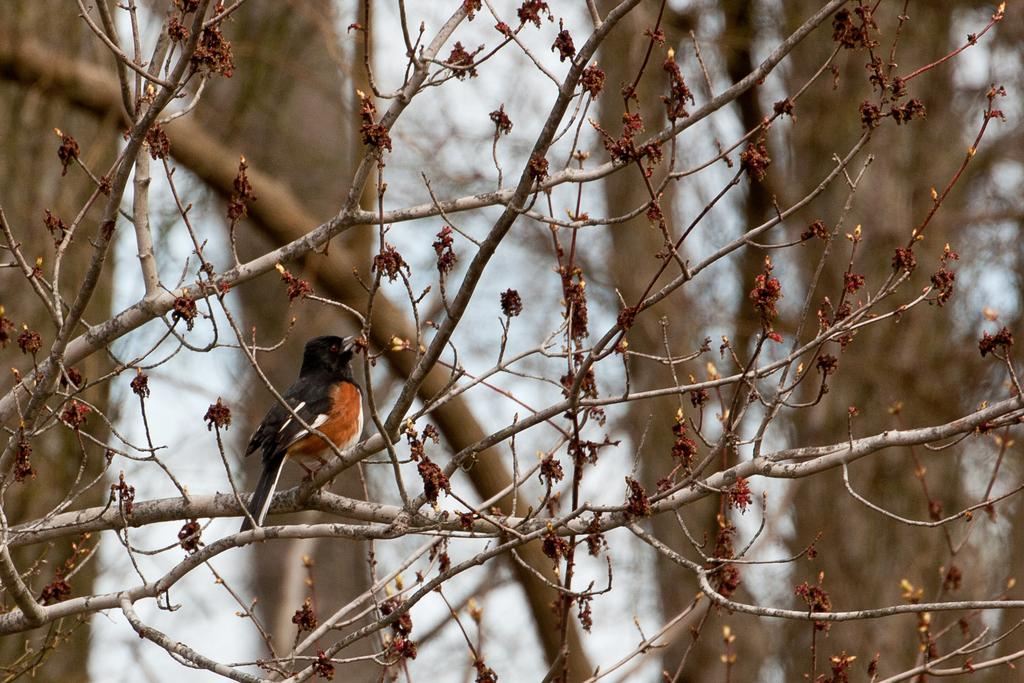What type of animal can be seen in the image? There is a bird in the image. What colors are present on the bird? The bird has brown and black colors. Where is the bird located in the image? The bird is sitting on a stem. What can be observed in the background of the image? There are many trees in the image. What type of cake is being served at the play in the image? There is no cake or play present in the image; it features a bird sitting on a stem with trees in the background. 